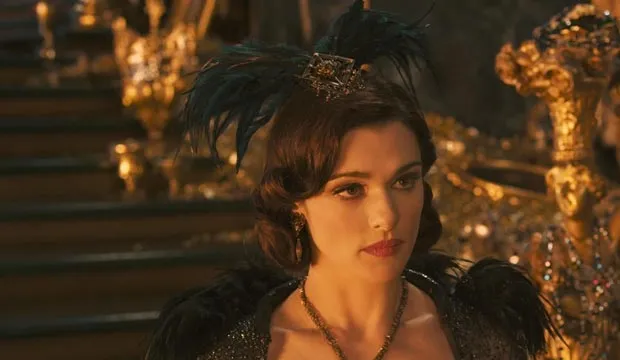Describe the atmosphere and mood in the image. The atmosphere in the image is one of opulence and authority, with a hint of tension. The golden throne and elaborate surroundings suggest a setting of grandeur and power. However, the woman's serious expression and the dark tones of her black and gold attire convey a mood of contemplation and gravity. The interplay of light and shadow adds to the dramatic feel, hinting at a critical moment in a story of power and intrigue. 